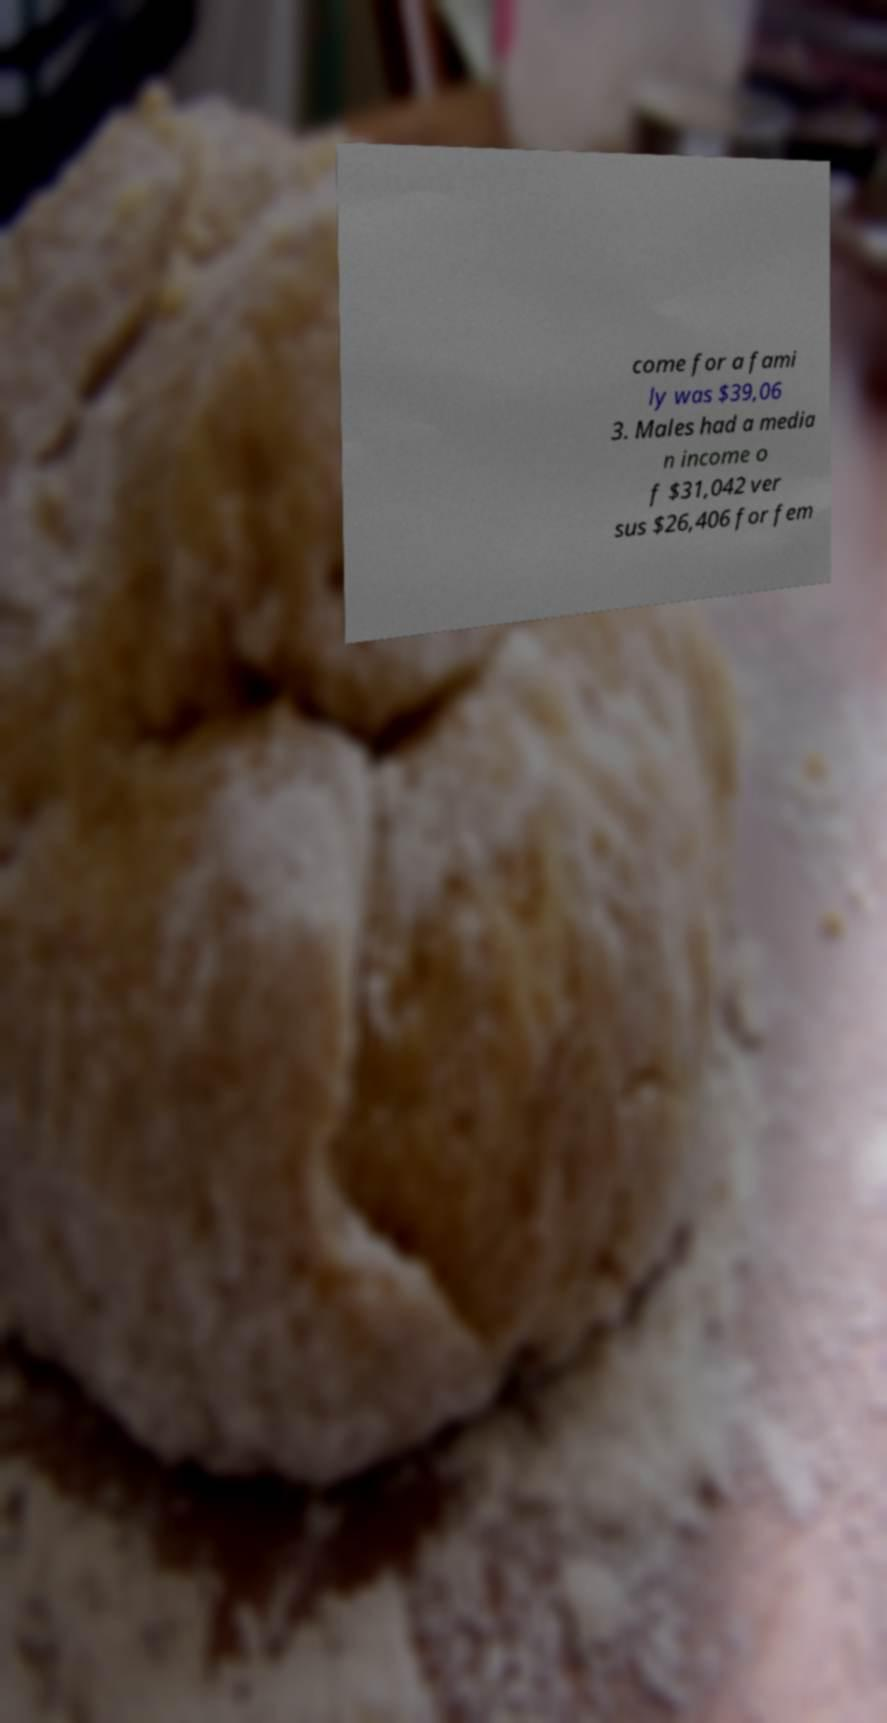Could you extract and type out the text from this image? come for a fami ly was $39,06 3. Males had a media n income o f $31,042 ver sus $26,406 for fem 